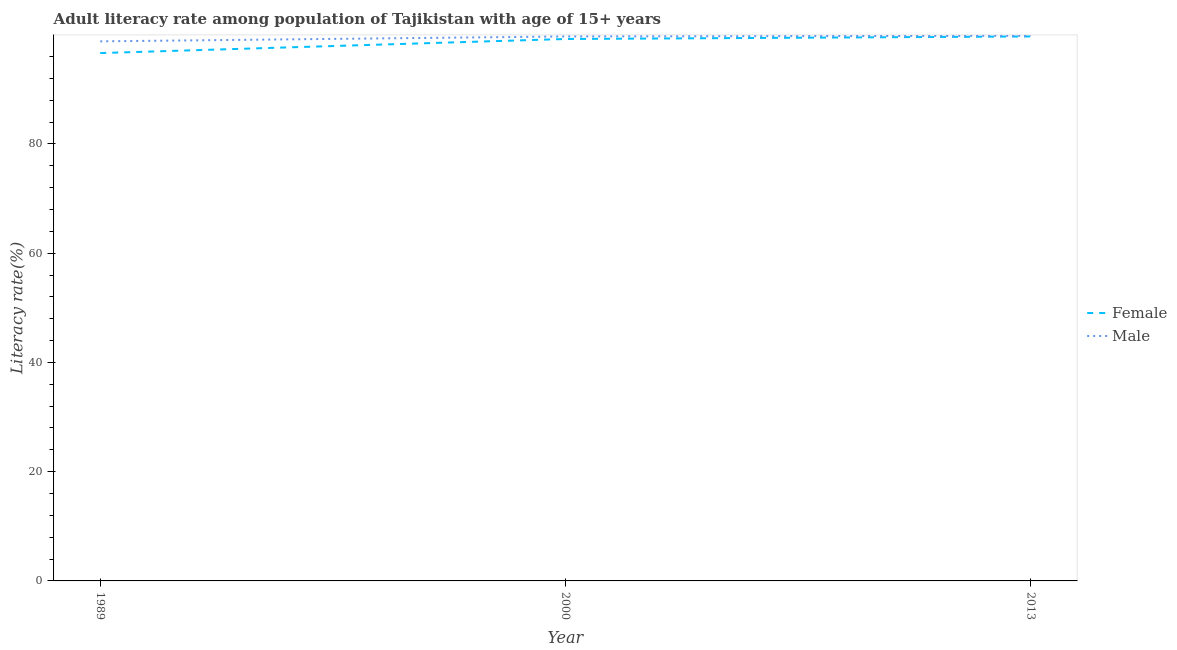Does the line corresponding to male adult literacy rate intersect with the line corresponding to female adult literacy rate?
Your answer should be compact. No. Is the number of lines equal to the number of legend labels?
Give a very brief answer. Yes. What is the male adult literacy rate in 1989?
Your answer should be very brief. 98.79. Across all years, what is the maximum female adult literacy rate?
Your answer should be compact. 99.68. Across all years, what is the minimum female adult literacy rate?
Make the answer very short. 96.64. In which year was the male adult literacy rate minimum?
Offer a terse response. 1989. What is the total female adult literacy rate in the graph?
Make the answer very short. 295.55. What is the difference between the female adult literacy rate in 1989 and that in 2013?
Ensure brevity in your answer.  -3.04. What is the difference between the male adult literacy rate in 1989 and the female adult literacy rate in 2013?
Make the answer very short. -0.89. What is the average female adult literacy rate per year?
Your answer should be compact. 98.52. In the year 2013, what is the difference between the male adult literacy rate and female adult literacy rate?
Your answer should be very brief. 0.13. What is the ratio of the female adult literacy rate in 2000 to that in 2013?
Keep it short and to the point. 1. Is the female adult literacy rate in 1989 less than that in 2000?
Offer a terse response. Yes. Is the difference between the male adult literacy rate in 2000 and 2013 greater than the difference between the female adult literacy rate in 2000 and 2013?
Keep it short and to the point. Yes. What is the difference between the highest and the second highest male adult literacy rate?
Ensure brevity in your answer.  0.13. What is the difference between the highest and the lowest male adult literacy rate?
Provide a short and direct response. 1.03. In how many years, is the male adult literacy rate greater than the average male adult literacy rate taken over all years?
Ensure brevity in your answer.  2. Is the sum of the female adult literacy rate in 1989 and 2000 greater than the maximum male adult literacy rate across all years?
Provide a short and direct response. Yes. How many lines are there?
Keep it short and to the point. 2. Are the values on the major ticks of Y-axis written in scientific E-notation?
Keep it short and to the point. No. Does the graph contain any zero values?
Offer a very short reply. No. Where does the legend appear in the graph?
Offer a terse response. Center right. What is the title of the graph?
Your answer should be compact. Adult literacy rate among population of Tajikistan with age of 15+ years. What is the label or title of the X-axis?
Make the answer very short. Year. What is the label or title of the Y-axis?
Offer a very short reply. Literacy rate(%). What is the Literacy rate(%) in Female in 1989?
Provide a short and direct response. 96.64. What is the Literacy rate(%) in Male in 1989?
Provide a succinct answer. 98.79. What is the Literacy rate(%) in Female in 2000?
Your response must be concise. 99.22. What is the Literacy rate(%) of Male in 2000?
Keep it short and to the point. 99.68. What is the Literacy rate(%) in Female in 2013?
Offer a terse response. 99.68. What is the Literacy rate(%) of Male in 2013?
Keep it short and to the point. 99.82. Across all years, what is the maximum Literacy rate(%) of Female?
Keep it short and to the point. 99.68. Across all years, what is the maximum Literacy rate(%) of Male?
Offer a terse response. 99.82. Across all years, what is the minimum Literacy rate(%) of Female?
Ensure brevity in your answer.  96.64. Across all years, what is the minimum Literacy rate(%) of Male?
Your response must be concise. 98.79. What is the total Literacy rate(%) of Female in the graph?
Offer a very short reply. 295.55. What is the total Literacy rate(%) of Male in the graph?
Keep it short and to the point. 298.29. What is the difference between the Literacy rate(%) of Female in 1989 and that in 2000?
Make the answer very short. -2.58. What is the difference between the Literacy rate(%) of Male in 1989 and that in 2000?
Your answer should be very brief. -0.89. What is the difference between the Literacy rate(%) in Female in 1989 and that in 2013?
Offer a very short reply. -3.04. What is the difference between the Literacy rate(%) of Male in 1989 and that in 2013?
Provide a succinct answer. -1.03. What is the difference between the Literacy rate(%) in Female in 2000 and that in 2013?
Your answer should be very brief. -0.46. What is the difference between the Literacy rate(%) in Male in 2000 and that in 2013?
Your response must be concise. -0.13. What is the difference between the Literacy rate(%) in Female in 1989 and the Literacy rate(%) in Male in 2000?
Your answer should be compact. -3.04. What is the difference between the Literacy rate(%) in Female in 1989 and the Literacy rate(%) in Male in 2013?
Keep it short and to the point. -3.17. What is the difference between the Literacy rate(%) in Female in 2000 and the Literacy rate(%) in Male in 2013?
Make the answer very short. -0.59. What is the average Literacy rate(%) in Female per year?
Give a very brief answer. 98.52. What is the average Literacy rate(%) of Male per year?
Make the answer very short. 99.43. In the year 1989, what is the difference between the Literacy rate(%) in Female and Literacy rate(%) in Male?
Make the answer very short. -2.15. In the year 2000, what is the difference between the Literacy rate(%) of Female and Literacy rate(%) of Male?
Offer a terse response. -0.46. In the year 2013, what is the difference between the Literacy rate(%) of Female and Literacy rate(%) of Male?
Your response must be concise. -0.13. What is the ratio of the Literacy rate(%) in Female in 1989 to that in 2000?
Give a very brief answer. 0.97. What is the ratio of the Literacy rate(%) in Female in 1989 to that in 2013?
Provide a short and direct response. 0.97. What is the ratio of the Literacy rate(%) of Male in 1989 to that in 2013?
Your response must be concise. 0.99. What is the ratio of the Literacy rate(%) of Female in 2000 to that in 2013?
Provide a short and direct response. 1. What is the difference between the highest and the second highest Literacy rate(%) in Female?
Provide a short and direct response. 0.46. What is the difference between the highest and the second highest Literacy rate(%) of Male?
Your answer should be compact. 0.13. What is the difference between the highest and the lowest Literacy rate(%) of Female?
Your answer should be very brief. 3.04. What is the difference between the highest and the lowest Literacy rate(%) in Male?
Ensure brevity in your answer.  1.03. 